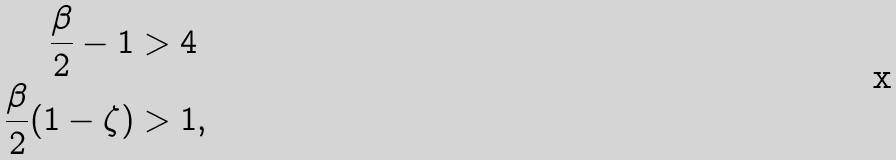<formula> <loc_0><loc_0><loc_500><loc_500>\frac { \beta } { 2 } - 1 & > 4 \\ \frac { \beta } { 2 } ( 1 - \zeta ) & > 1 ,</formula> 